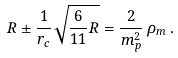Convert formula to latex. <formula><loc_0><loc_0><loc_500><loc_500>R \pm \frac { 1 } { r _ { c } } \sqrt { \frac { 6 } { 1 1 } R } = \frac { 2 } { m _ { p } ^ { 2 } } \, \rho _ { m } \, .</formula> 